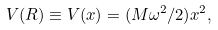<formula> <loc_0><loc_0><loc_500><loc_500>V ( { R } ) \equiv V ( x ) = ( M \omega ^ { 2 } / 2 ) x ^ { 2 } ,</formula> 